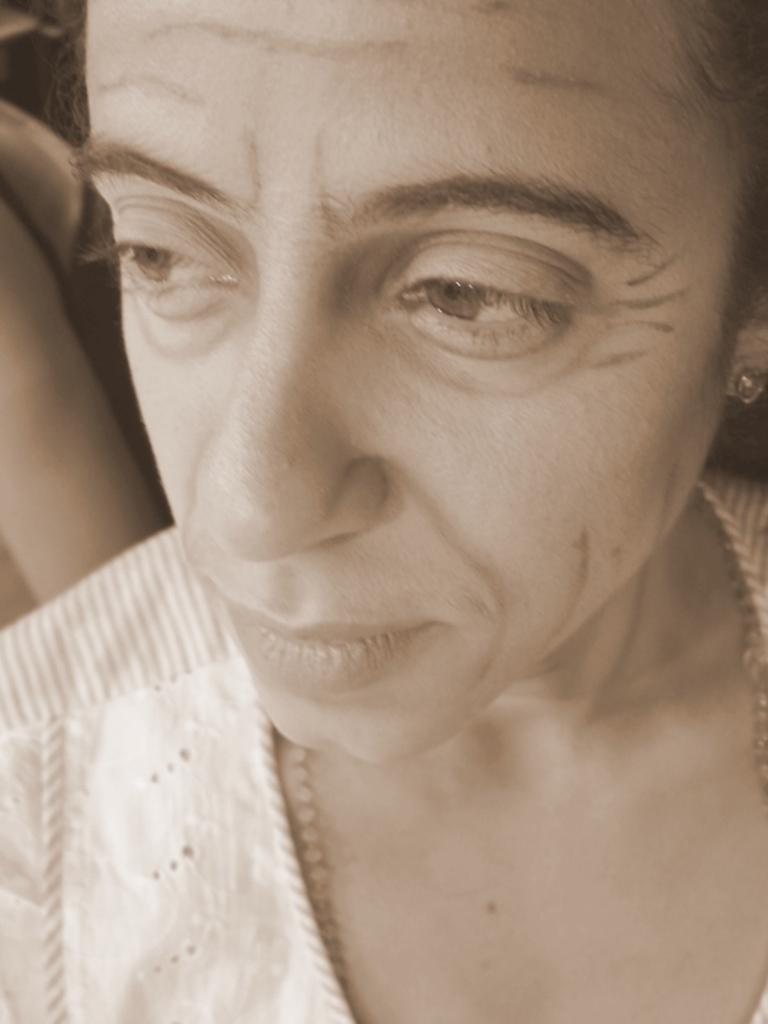What is the main subject of the image? There is a face of a person in the image. Can you describe the facial features of the person? The provided facts do not include specific details about the person's facial features. Is the person's face the only element in the image? The provided facts do not mention any other elements in the image besides the face of the person. What type of egg is being used to cover the camera in the image? There is no egg or camera present in the image; it only features the face of a person. 